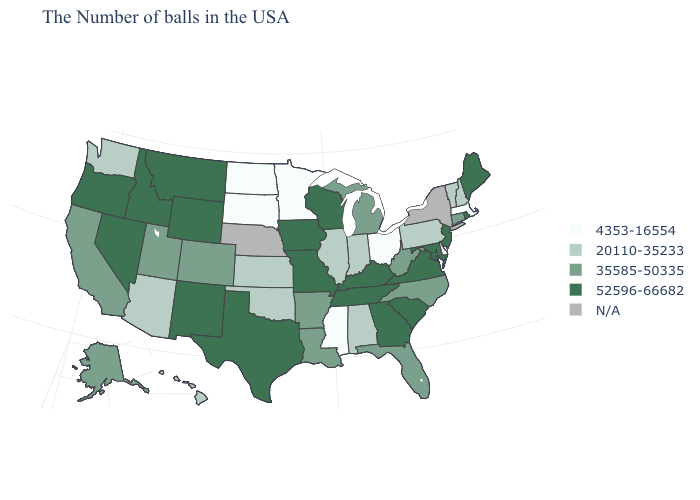Which states have the lowest value in the USA?
Short answer required. Massachusetts, Delaware, Ohio, Mississippi, Minnesota, South Dakota, North Dakota. Which states have the lowest value in the USA?
Give a very brief answer. Massachusetts, Delaware, Ohio, Mississippi, Minnesota, South Dakota, North Dakota. What is the value of North Dakota?
Short answer required. 4353-16554. Does Ohio have the lowest value in the USA?
Write a very short answer. Yes. What is the highest value in the West ?
Give a very brief answer. 52596-66682. Does Michigan have the lowest value in the USA?
Keep it brief. No. What is the highest value in the Northeast ?
Answer briefly. 52596-66682. Which states have the highest value in the USA?
Write a very short answer. Maine, Rhode Island, New Jersey, Maryland, Virginia, South Carolina, Georgia, Kentucky, Tennessee, Wisconsin, Missouri, Iowa, Texas, Wyoming, New Mexico, Montana, Idaho, Nevada, Oregon. Name the states that have a value in the range 35585-50335?
Be succinct. Connecticut, North Carolina, West Virginia, Florida, Michigan, Louisiana, Arkansas, Colorado, Utah, California, Alaska. What is the highest value in states that border Utah?
Give a very brief answer. 52596-66682. What is the value of Hawaii?
Short answer required. 20110-35233. Which states have the highest value in the USA?
Quick response, please. Maine, Rhode Island, New Jersey, Maryland, Virginia, South Carolina, Georgia, Kentucky, Tennessee, Wisconsin, Missouri, Iowa, Texas, Wyoming, New Mexico, Montana, Idaho, Nevada, Oregon. Name the states that have a value in the range 20110-35233?
Short answer required. New Hampshire, Vermont, Pennsylvania, Indiana, Alabama, Illinois, Kansas, Oklahoma, Arizona, Washington, Hawaii. Does the first symbol in the legend represent the smallest category?
Write a very short answer. Yes. Name the states that have a value in the range 35585-50335?
Short answer required. Connecticut, North Carolina, West Virginia, Florida, Michigan, Louisiana, Arkansas, Colorado, Utah, California, Alaska. 